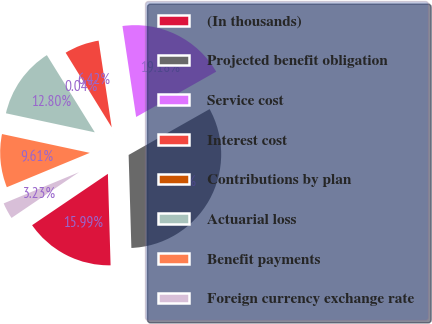<chart> <loc_0><loc_0><loc_500><loc_500><pie_chart><fcel>(In thousands)<fcel>Projected benefit obligation<fcel>Service cost<fcel>Interest cost<fcel>Contributions by plan<fcel>Actuarial loss<fcel>Benefit payments<fcel>Foreign currency exchange rate<nl><fcel>15.99%<fcel>32.73%<fcel>19.18%<fcel>6.42%<fcel>0.04%<fcel>12.8%<fcel>9.61%<fcel>3.23%<nl></chart> 